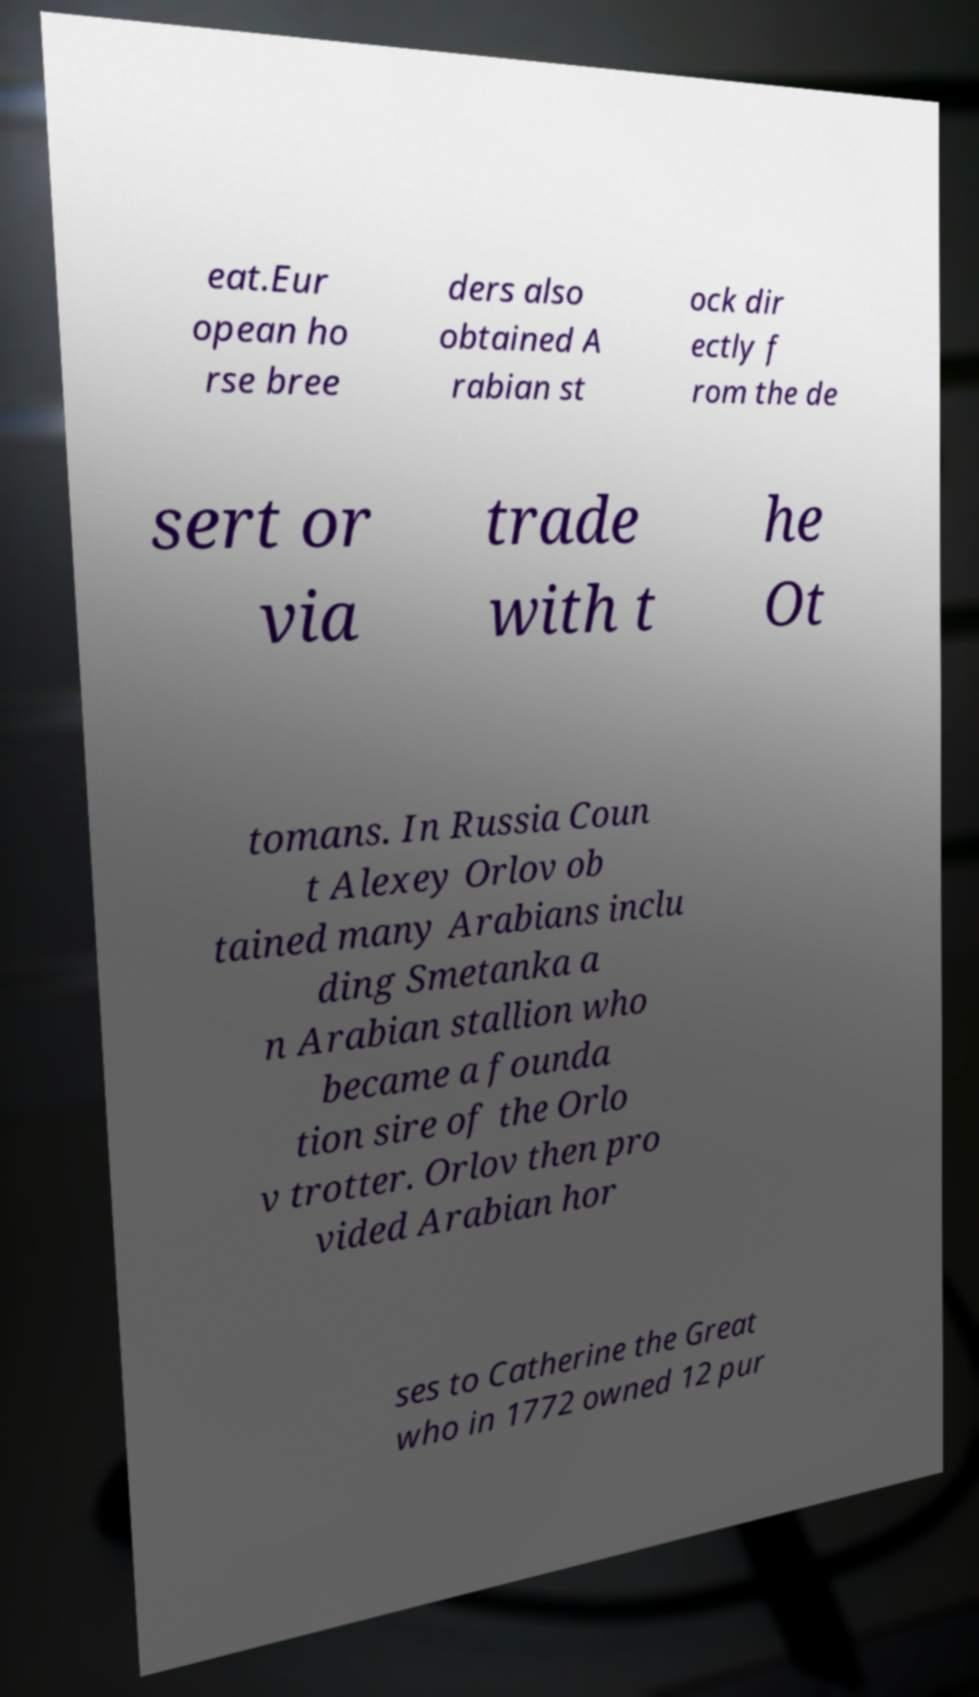For documentation purposes, I need the text within this image transcribed. Could you provide that? eat.Eur opean ho rse bree ders also obtained A rabian st ock dir ectly f rom the de sert or via trade with t he Ot tomans. In Russia Coun t Alexey Orlov ob tained many Arabians inclu ding Smetanka a n Arabian stallion who became a founda tion sire of the Orlo v trotter. Orlov then pro vided Arabian hor ses to Catherine the Great who in 1772 owned 12 pur 